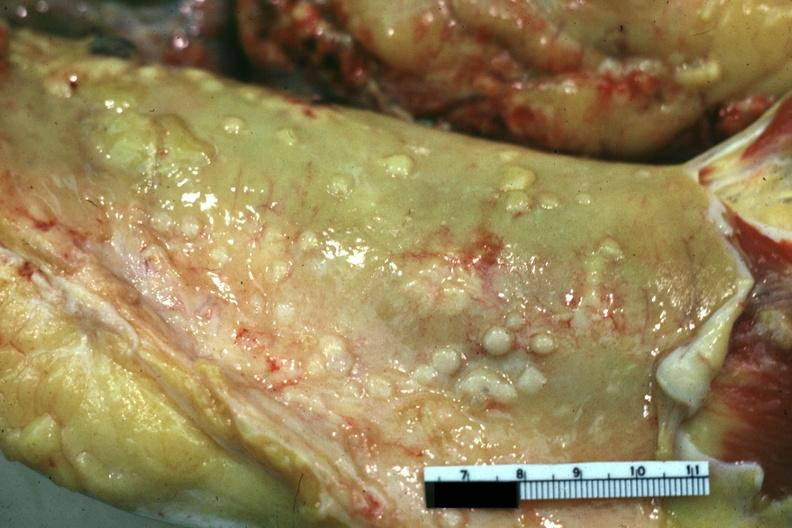does this image show close-up view of metastatic lesions color not the best papillary serous adenocarcinoma of ovary?
Answer the question using a single word or phrase. Yes 